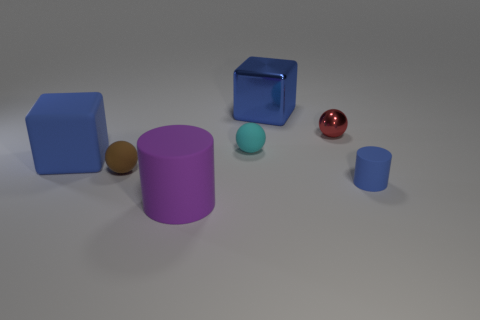There is a cylinder to the right of the small cyan thing; is its size the same as the blue block to the left of the brown sphere?
Make the answer very short. No. How many large blocks have the same color as the large metallic thing?
Your answer should be very brief. 1. What is the material of the cylinder that is the same color as the big shiny thing?
Offer a terse response. Rubber. Are there more tiny cyan things right of the blue cylinder than metallic blocks?
Your answer should be compact. No. Is the shape of the tiny blue matte object the same as the brown object?
Provide a short and direct response. No. How many large purple objects are made of the same material as the purple cylinder?
Offer a terse response. 0. The cyan matte thing that is the same shape as the brown rubber thing is what size?
Offer a very short reply. Small. Do the blue cylinder and the red thing have the same size?
Make the answer very short. Yes. There is a blue thing that is to the left of the large matte thing that is right of the blue rubber object behind the brown ball; what is its shape?
Ensure brevity in your answer.  Cube. The metal thing that is the same shape as the large blue matte thing is what color?
Provide a short and direct response. Blue. 